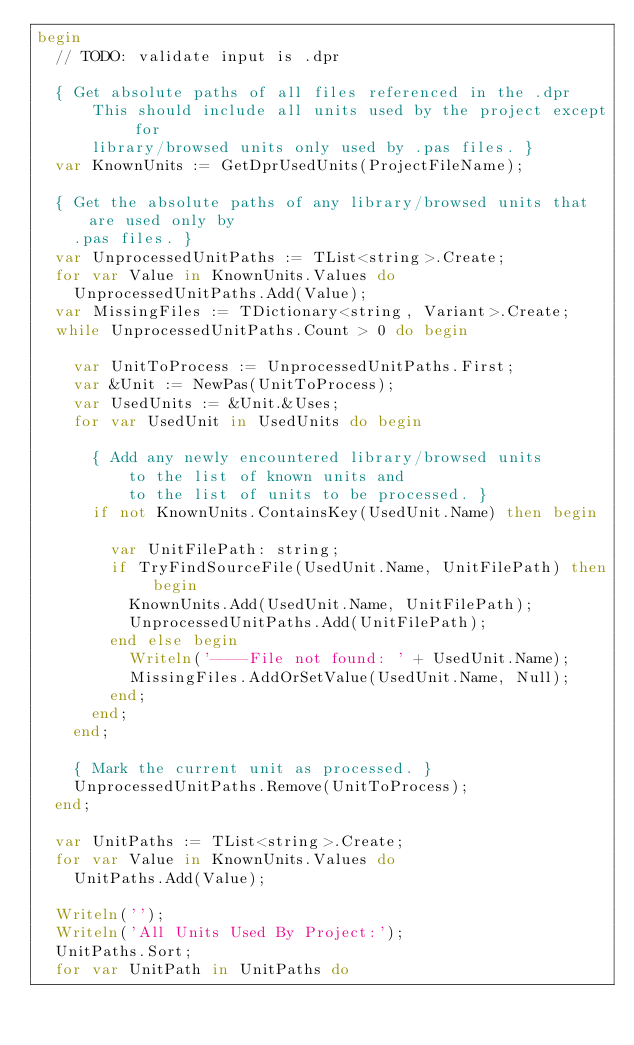<code> <loc_0><loc_0><loc_500><loc_500><_Pascal_>begin
  // TODO: validate input is .dpr

  { Get absolute paths of all files referenced in the .dpr
      This should include all units used by the project except for
      library/browsed units only used by .pas files. }
  var KnownUnits := GetDprUsedUnits(ProjectFileName);

  { Get the absolute paths of any library/browsed units that are used only by
    .pas files. }
  var UnprocessedUnitPaths := TList<string>.Create;
  for var Value in KnownUnits.Values do
    UnprocessedUnitPaths.Add(Value);
  var MissingFiles := TDictionary<string, Variant>.Create;
  while UnprocessedUnitPaths.Count > 0 do begin

    var UnitToProcess := UnprocessedUnitPaths.First;
    var &Unit := NewPas(UnitToProcess);
    var UsedUnits := &Unit.&Uses;
    for var UsedUnit in UsedUnits do begin

      { Add any newly encountered library/browsed units
          to the list of known units and
          to the list of units to be processed. }
      if not KnownUnits.ContainsKey(UsedUnit.Name) then begin

        var UnitFilePath: string;
        if TryFindSourceFile(UsedUnit.Name, UnitFilePath) then begin
          KnownUnits.Add(UsedUnit.Name, UnitFilePath);
          UnprocessedUnitPaths.Add(UnitFilePath);
        end else begin
          Writeln('----File not found: ' + UsedUnit.Name);
          MissingFiles.AddOrSetValue(UsedUnit.Name, Null);
        end;
      end;
    end;

    { Mark the current unit as processed. }
    UnprocessedUnitPaths.Remove(UnitToProcess);
  end;

  var UnitPaths := TList<string>.Create;
  for var Value in KnownUnits.Values do
    UnitPaths.Add(Value);

  Writeln('');
  Writeln('All Units Used By Project:');
  UnitPaths.Sort;
  for var UnitPath in UnitPaths do</code> 